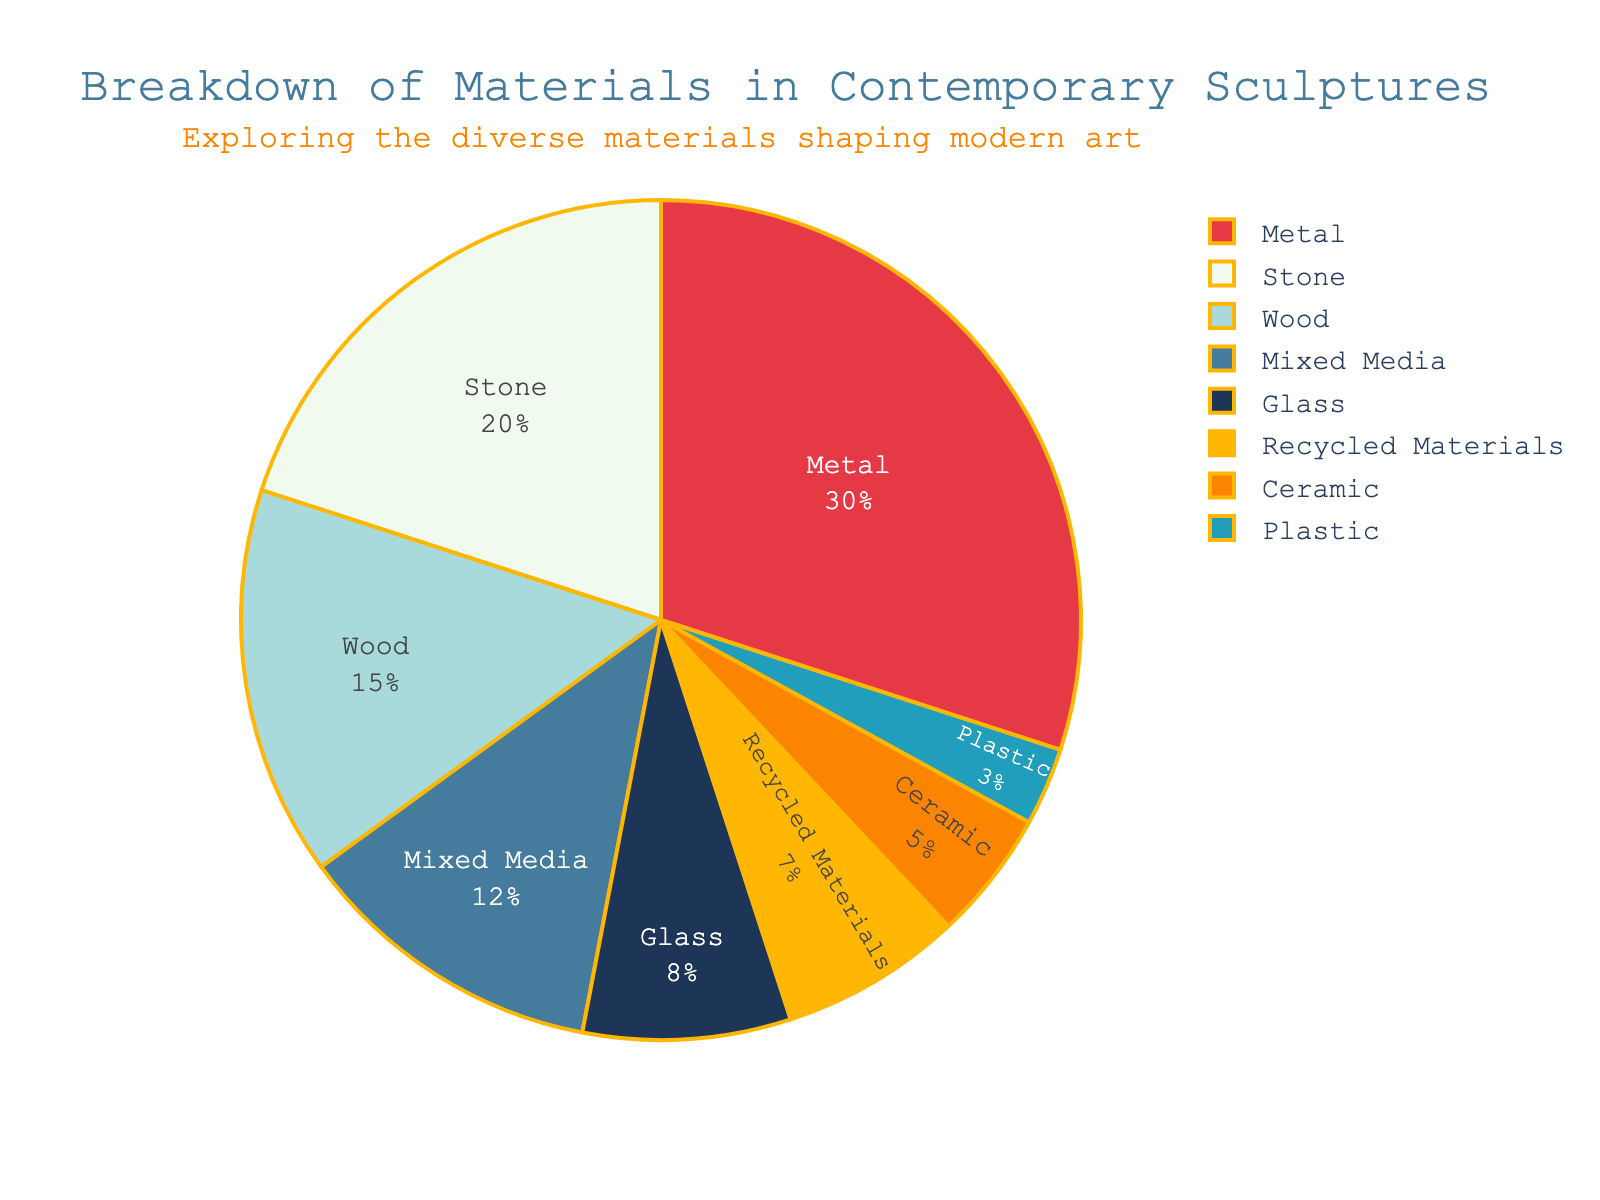What is the most commonly used material in contemporary sculptures? To determine this, look for the material with the highest percentage in the pie chart. Metal has the largest slice, representing 30%.
Answer: Metal What is the combined percentage of Stone and Wood materials used in contemporary sculptures? Add the percentages of Stone and Wood. Stone is 20% and Wood is 15%. Therefore, 20% + 15% = 35%.
Answer: 35% Which material is used less, Glass or Plastic? Compare the percentages for Glass and Plastic. Glass has a percentage of 8%, while Plastic has 3%. Glass is more than Plastic, so Plastic is used less.
Answer: Plastic How much more is the percentage of Metal compared to Recycled Materials? Subtract the percentage of Recycled Materials from Metal. Metal is 30%, and Recycled Materials are 7%. So, 30% - 7% = 23%.
Answer: 23% Which material represents the smallest percentage? Look for the material with the smallest slice in the pie chart. Plastic has the smallest slice at 3%.
Answer: Plastic How does the percentage of Mixed Media compare to that of Ceramic? Compare the percentages of Mixed Media and Ceramic. Mixed Media is 12%, while Ceramic is 5%. Mixed Media is more than twice the percentage of Ceramic.
Answer: Mixed Media is more, more than twice Ceramic What is the percentage difference between the most and the least used materials? Identify the most used (Metal at 30%) and the least used (Plastic at 3%) materials, and subtract the latter from the former. 30% - 3% = 27%.
Answer: 27% How many materials have a percentage greater than 10%? Look at the pie chart slices to identify materials with percentages above 10%. Metal (30%), Stone (20%), Wood (15%), and Mixed Media (12%) all exceed 10%. There are 4 such materials.
Answer: 4 What is the average percentage use of Glass, Plastic, and Ceramic in contemporary sculptures? Add the percentages for Glass (8%), Plastic (3%), and Ceramic (5%), then divide by 3. (8% + 3% + 5%) / 3 = 16% / 3 = approximately 5.33%.
Answer: Approximately 5.33% Which has a greater percentage, Stone or the combined percentage of Recycled Materials and Ceramic? Compare Stone's 20% with the sum of Recycled Materials and Ceramic (7% + 5%). 7% + 5% = 12%. Since 20% > 12%, Stone is greater.
Answer: Stone 